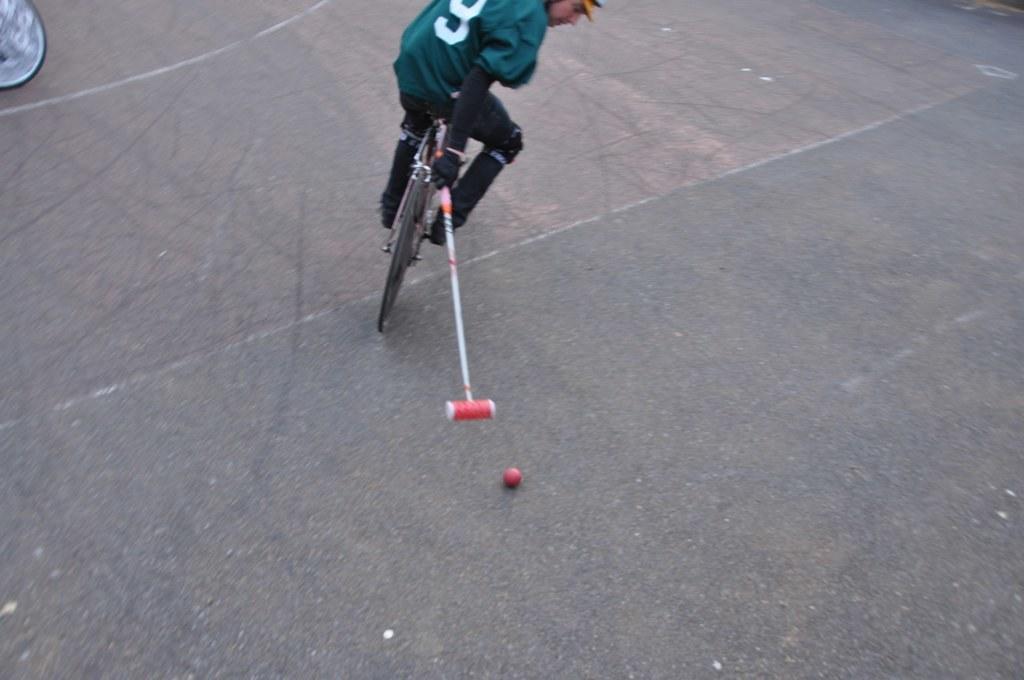In one or two sentences, can you explain what this image depicts? In the image we can see a person wearing clothes, shoes, gloves and the person is riding on the bicycle and holding an object. Here we can see the ball and the road. 